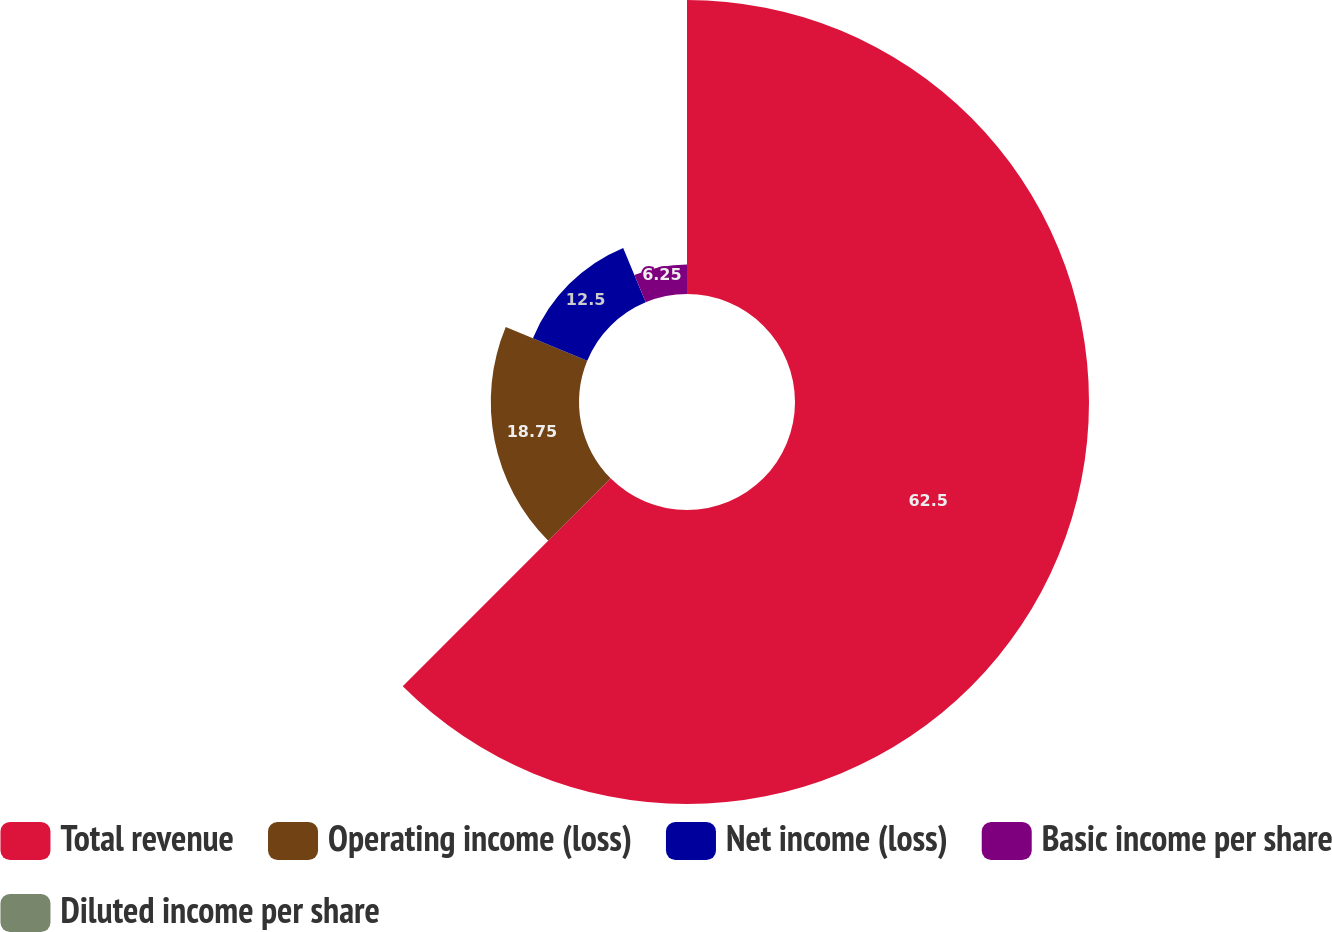<chart> <loc_0><loc_0><loc_500><loc_500><pie_chart><fcel>Total revenue<fcel>Operating income (loss)<fcel>Net income (loss)<fcel>Basic income per share<fcel>Diluted income per share<nl><fcel>62.5%<fcel>18.75%<fcel>12.5%<fcel>6.25%<fcel>0.0%<nl></chart> 